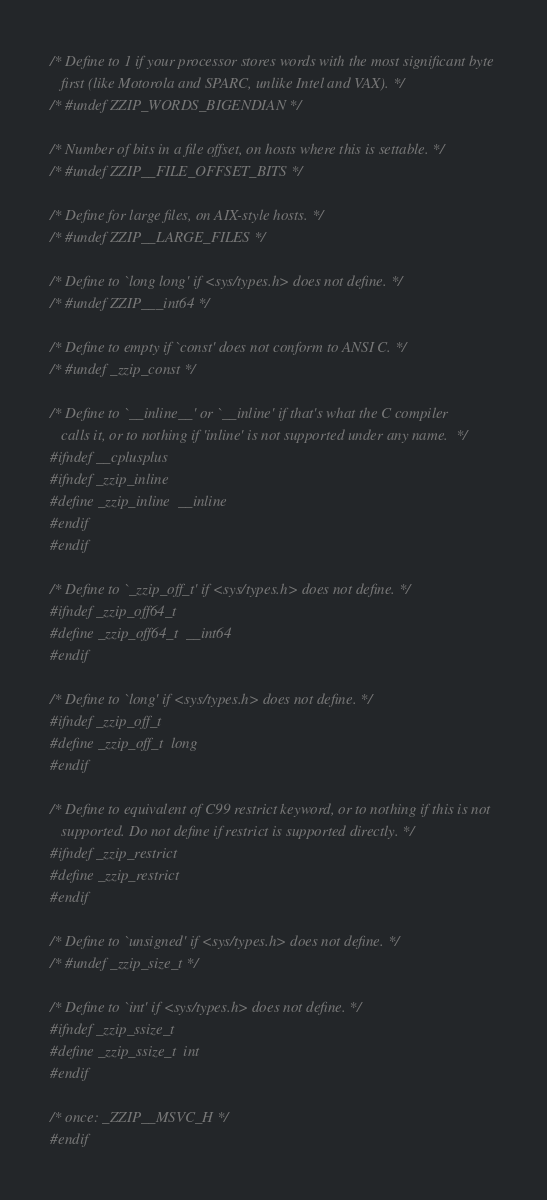Convert code to text. <code><loc_0><loc_0><loc_500><loc_500><_C_>/* Define to 1 if your processor stores words with the most significant byte
   first (like Motorola and SPARC, unlike Intel and VAX). */
/* #undef ZZIP_WORDS_BIGENDIAN */

/* Number of bits in a file offset, on hosts where this is settable. */
/* #undef ZZIP__FILE_OFFSET_BITS */

/* Define for large files, on AIX-style hosts. */
/* #undef ZZIP__LARGE_FILES */

/* Define to `long long' if <sys/types.h> does not define. */
/* #undef ZZIP___int64 */

/* Define to empty if `const' does not conform to ANSI C. */
/* #undef _zzip_const */

/* Define to `__inline__' or `__inline' if that's what the C compiler
   calls it, or to nothing if 'inline' is not supported under any name.  */
#ifndef __cplusplus
#ifndef _zzip_inline 
#define _zzip_inline  __inline 
#endif
#endif

/* Define to `_zzip_off_t' if <sys/types.h> does not define. */
#ifndef _zzip_off64_t 
#define _zzip_off64_t  __int64 
#endif

/* Define to `long' if <sys/types.h> does not define. */
#ifndef _zzip_off_t 
#define _zzip_off_t  long 
#endif

/* Define to equivalent of C99 restrict keyword, or to nothing if this is not
   supported. Do not define if restrict is supported directly. */
#ifndef _zzip_restrict 
#define _zzip_restrict  
#endif

/* Define to `unsigned' if <sys/types.h> does not define. */
/* #undef _zzip_size_t */

/* Define to `int' if <sys/types.h> does not define. */
#ifndef _zzip_ssize_t 
#define _zzip_ssize_t  int 
#endif
 
/* once: _ZZIP__MSVC_H */
#endif
</code> 